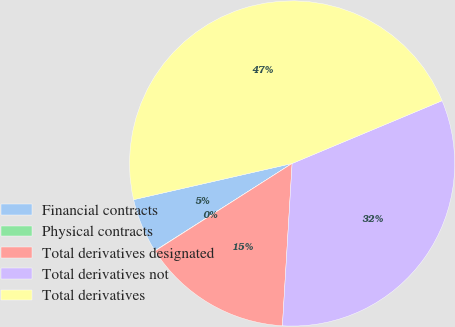Convert chart to OTSL. <chart><loc_0><loc_0><loc_500><loc_500><pie_chart><fcel>Financial contracts<fcel>Physical contracts<fcel>Total derivatives designated<fcel>Total derivatives not<fcel>Total derivatives<nl><fcel>5.44%<fcel>0.03%<fcel>15.01%<fcel>32.26%<fcel>47.27%<nl></chart> 